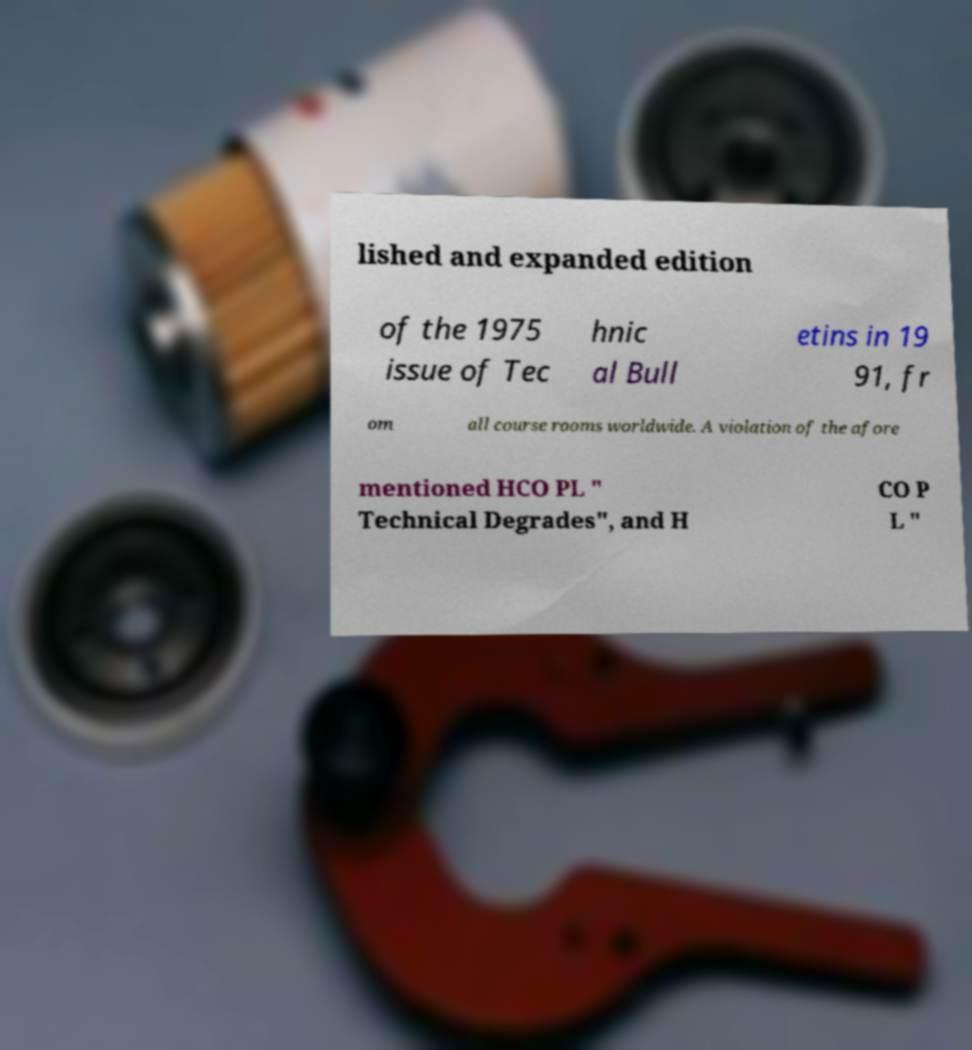For documentation purposes, I need the text within this image transcribed. Could you provide that? lished and expanded edition of the 1975 issue of Tec hnic al Bull etins in 19 91, fr om all course rooms worldwide. A violation of the afore mentioned HCO PL " Technical Degrades", and H CO P L " 